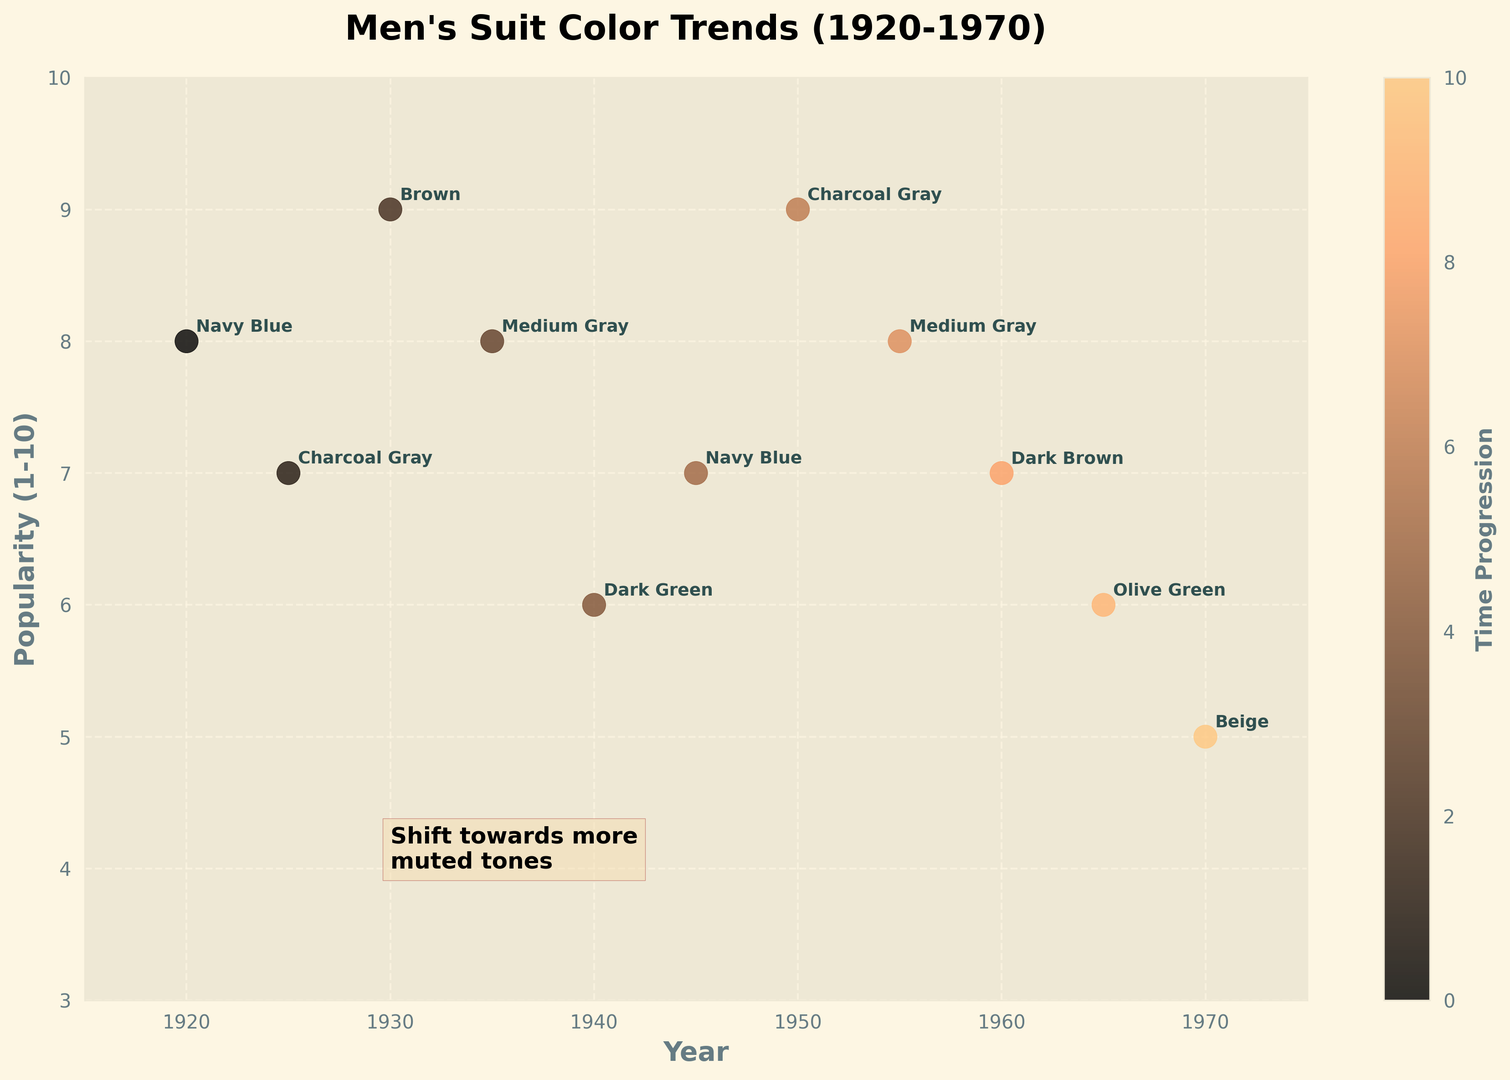Which color was dominant in both 1920 and 1945 for men's suits? The annotation next to the data points for 1920 and 1945 both indicate the color "Navy Blue".
Answer: Navy Blue What is the trend in color tones for men's suits from 1920 to 1970? The chart indicates a shift toward more muted and earthy tones, from brighter colors like Navy Blue to more subdued colors such as Beige by 1970.
Answer: More muted and earthy Which year had the highest popularity of men's suit colors, and what was the color? The highest point on the popularity axis (10) corresponds to the year 1950, with the color "Charcoal Gray" annotated next to it.
Answer: 1950, Charcoal Gray How does the popularity of men’s suit colors change from 1925 to 1950 for the color "Charcoal Gray"? Checking the annotated points for 1925 and 1950, "Charcoal Gray" had a popularity of 7 in 1925 and increased to 9 by 1950.
Answer: Increased Is there a clear pattern in the popularity of the color "Medium Gray" through the decades? Observing the chart, "Medium Gray" appears twice: once in 1935 and once in 1955, both with a popularity of 8, showing consistent popularity.
Answer: Consistent Which color had the lowest popularity in the dataset, and in which year? The lowest point on the popularity axis (5) corresponds to the year 1970, annotated with the color "Beige".
Answer: Beige, 1970 How many different colors are documented in the plot? By counting the distinct color annotations, there are a total of 8 different colors (Navy Blue, Charcoal Gray, Brown, Medium Gray, Dark Green, Dark Brown, Olive Green, Beige).
Answer: 8 What is the relationship between the popularity of men’s suit colors and the muted tones shift noted on the figure? The figure shows a shift toward more muted tones starting around 1940 and remains through to 1970. Popularity becomes more varied but generally stabilizes around 7-9.
Answer: Varied but stabilizes 